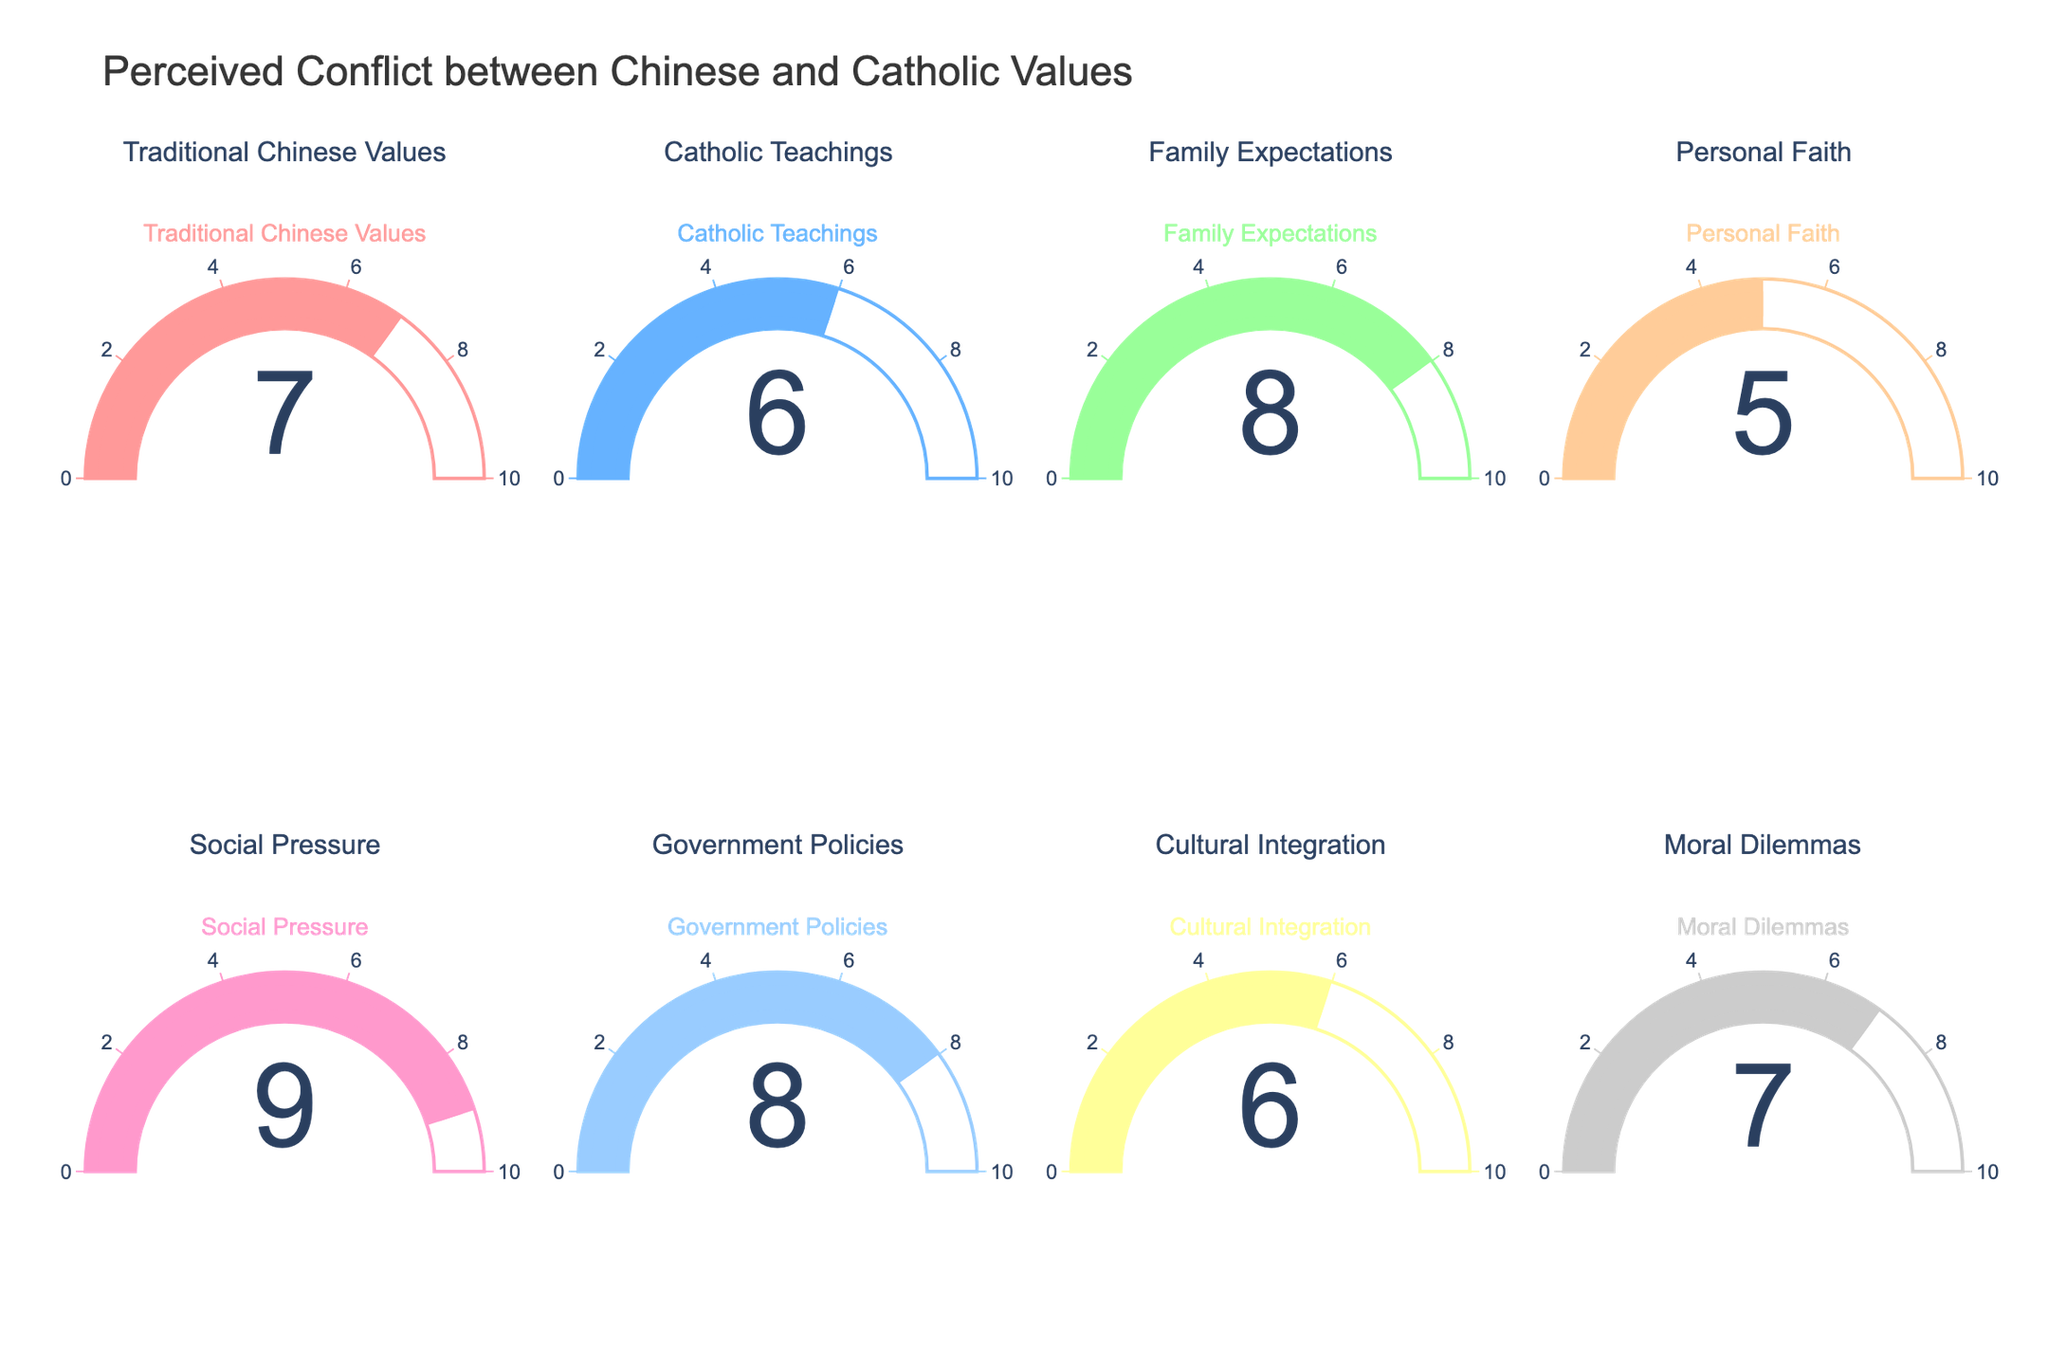What's the highest perceived conflict score? Look for the highest value displayed on the gauge charts. The highest score is 9.
Answer: 9 Which category has the lowest perceived conflict score? Find the gauge chart with the smallest number. The lowest value is in "Personal Faith" with a score of 5.
Answer: Personal Faith What's the average perceived conflict score across all categories? Add up all the values and divide by the number of categories: (7 + 6 + 8 + 5 + 9 + 8 + 6 + 7) / 8 = 56 / 8 = 7.
Answer: 7 How much higher is the perceived conflict score for Social Pressure compared to Catholic Teachings? Subtract the score for Catholic Teachings from the score for Social Pressure: 9 - 6 = 3.
Answer: 3 Are there more categories with a score of 7 or more, or with less than 7? Count the gauges with values 7 or higher and those with values less than 7. Seven or more: Traditional Chinese Values, Family Expectations, Social Pressure, Government Policies, Moral Dilemmas (5 categories). Less than 7: Catholic Teachings, Personal Faith, Cultural Integration (3 categories).
Answer: More categories with 7 or more Which categories have the same perceived conflict score? Look for repeated values among the gauge charts: Traditional Chinese Values and Moral Dilemmas both have a score of 7; Catholic Teachings and Cultural Integration both have a score of 6; Family Expectations and Government Policies both have a score of 8.
Answer: Traditional Chinese Values and Moral Dilemmas, Catholic Teachings and Cultural Integration, Family Expectations and Government Policies What's the sum of the perceived conflict scores for Traditional Chinese Values and Family Expectations? Add the values for these two categories: 7 + 8 = 15.
Answer: 15 If you could only address one category to reduce perceived conflict, which one would you focus on according to the figure? Choose the category with the highest perceived conflict score, which is Social Pressure with a score of 9.
Answer: Social Pressure 